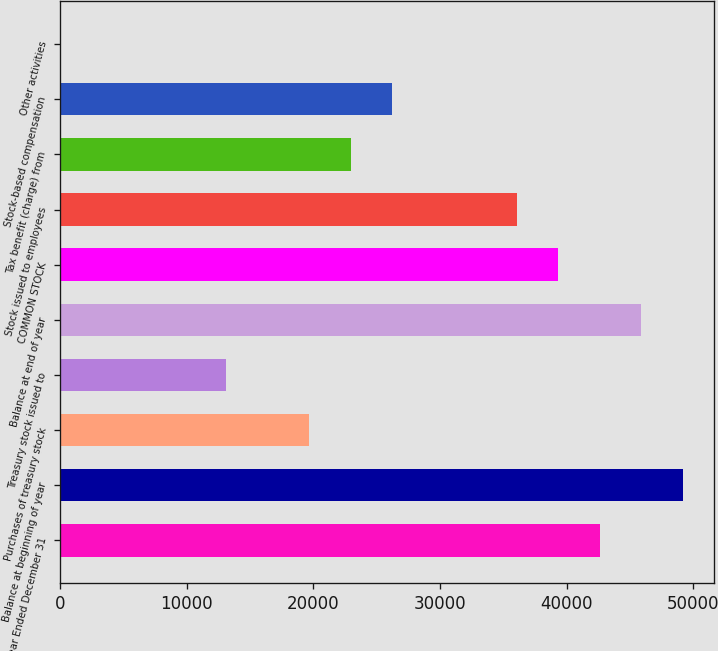Convert chart. <chart><loc_0><loc_0><loc_500><loc_500><bar_chart><fcel>Year Ended December 31<fcel>Balance at beginning of year<fcel>Purchases of treasury stock<fcel>Treasury stock issued to<fcel>Balance at end of year<fcel>COMMON STOCK<fcel>Stock issued to employees<fcel>Tax benefit (charge) from<fcel>Stock-based compensation<fcel>Other activities<nl><fcel>42625.8<fcel>49183<fcel>19675.6<fcel>13118.4<fcel>45904.4<fcel>39347.2<fcel>36068.6<fcel>22954.2<fcel>26232.8<fcel>4<nl></chart> 